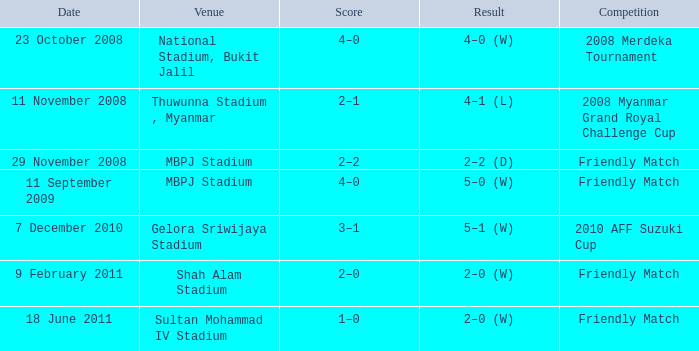What is the Venue of the Competition with a Result of 2–2 (d)? MBPJ Stadium. Would you mind parsing the complete table? {'header': ['Date', 'Venue', 'Score', 'Result', 'Competition'], 'rows': [['23 October 2008', 'National Stadium, Bukit Jalil', '4–0', '4–0 (W)', '2008 Merdeka Tournament'], ['11 November 2008', 'Thuwunna Stadium , Myanmar', '2–1', '4–1 (L)', '2008 Myanmar Grand Royal Challenge Cup'], ['29 November 2008', 'MBPJ Stadium', '2–2', '2–2 (D)', 'Friendly Match'], ['11 September 2009', 'MBPJ Stadium', '4–0', '5–0 (W)', 'Friendly Match'], ['7 December 2010', 'Gelora Sriwijaya Stadium', '3–1', '5–1 (W)', '2010 AFF Suzuki Cup'], ['9 February 2011', 'Shah Alam Stadium', '2–0', '2–0 (W)', 'Friendly Match'], ['18 June 2011', 'Sultan Mohammad IV Stadium', '1–0', '2–0 (W)', 'Friendly Match']]} 